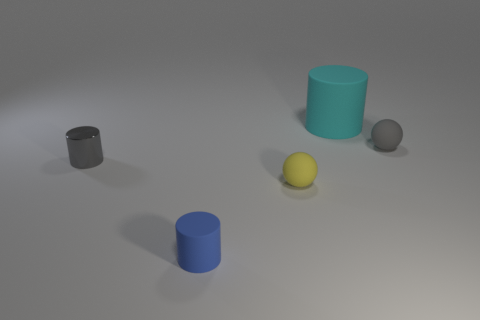Is there any other thing that has the same material as the gray cylinder?
Offer a terse response. No. Is the number of yellow spheres that are behind the gray metal cylinder greater than the number of cylinders behind the tiny yellow matte object?
Your answer should be compact. No. How many small gray things are to the left of the tiny gray thing to the left of the small blue rubber cylinder?
Provide a succinct answer. 0. Are there any tiny objects that have the same color as the small metallic cylinder?
Make the answer very short. Yes. Is the yellow thing the same size as the gray ball?
Give a very brief answer. Yes. What is the material of the tiny ball that is on the right side of the cylinder behind the gray ball?
Your response must be concise. Rubber. There is another small blue thing that is the same shape as the small shiny object; what is its material?
Offer a very short reply. Rubber. There is a cylinder behind the gray matte ball; is its size the same as the metal cylinder?
Ensure brevity in your answer.  No. What number of rubber things are blue cylinders or small red cubes?
Your response must be concise. 1. What material is the object that is both in front of the large cylinder and to the right of the small yellow rubber sphere?
Make the answer very short. Rubber. 